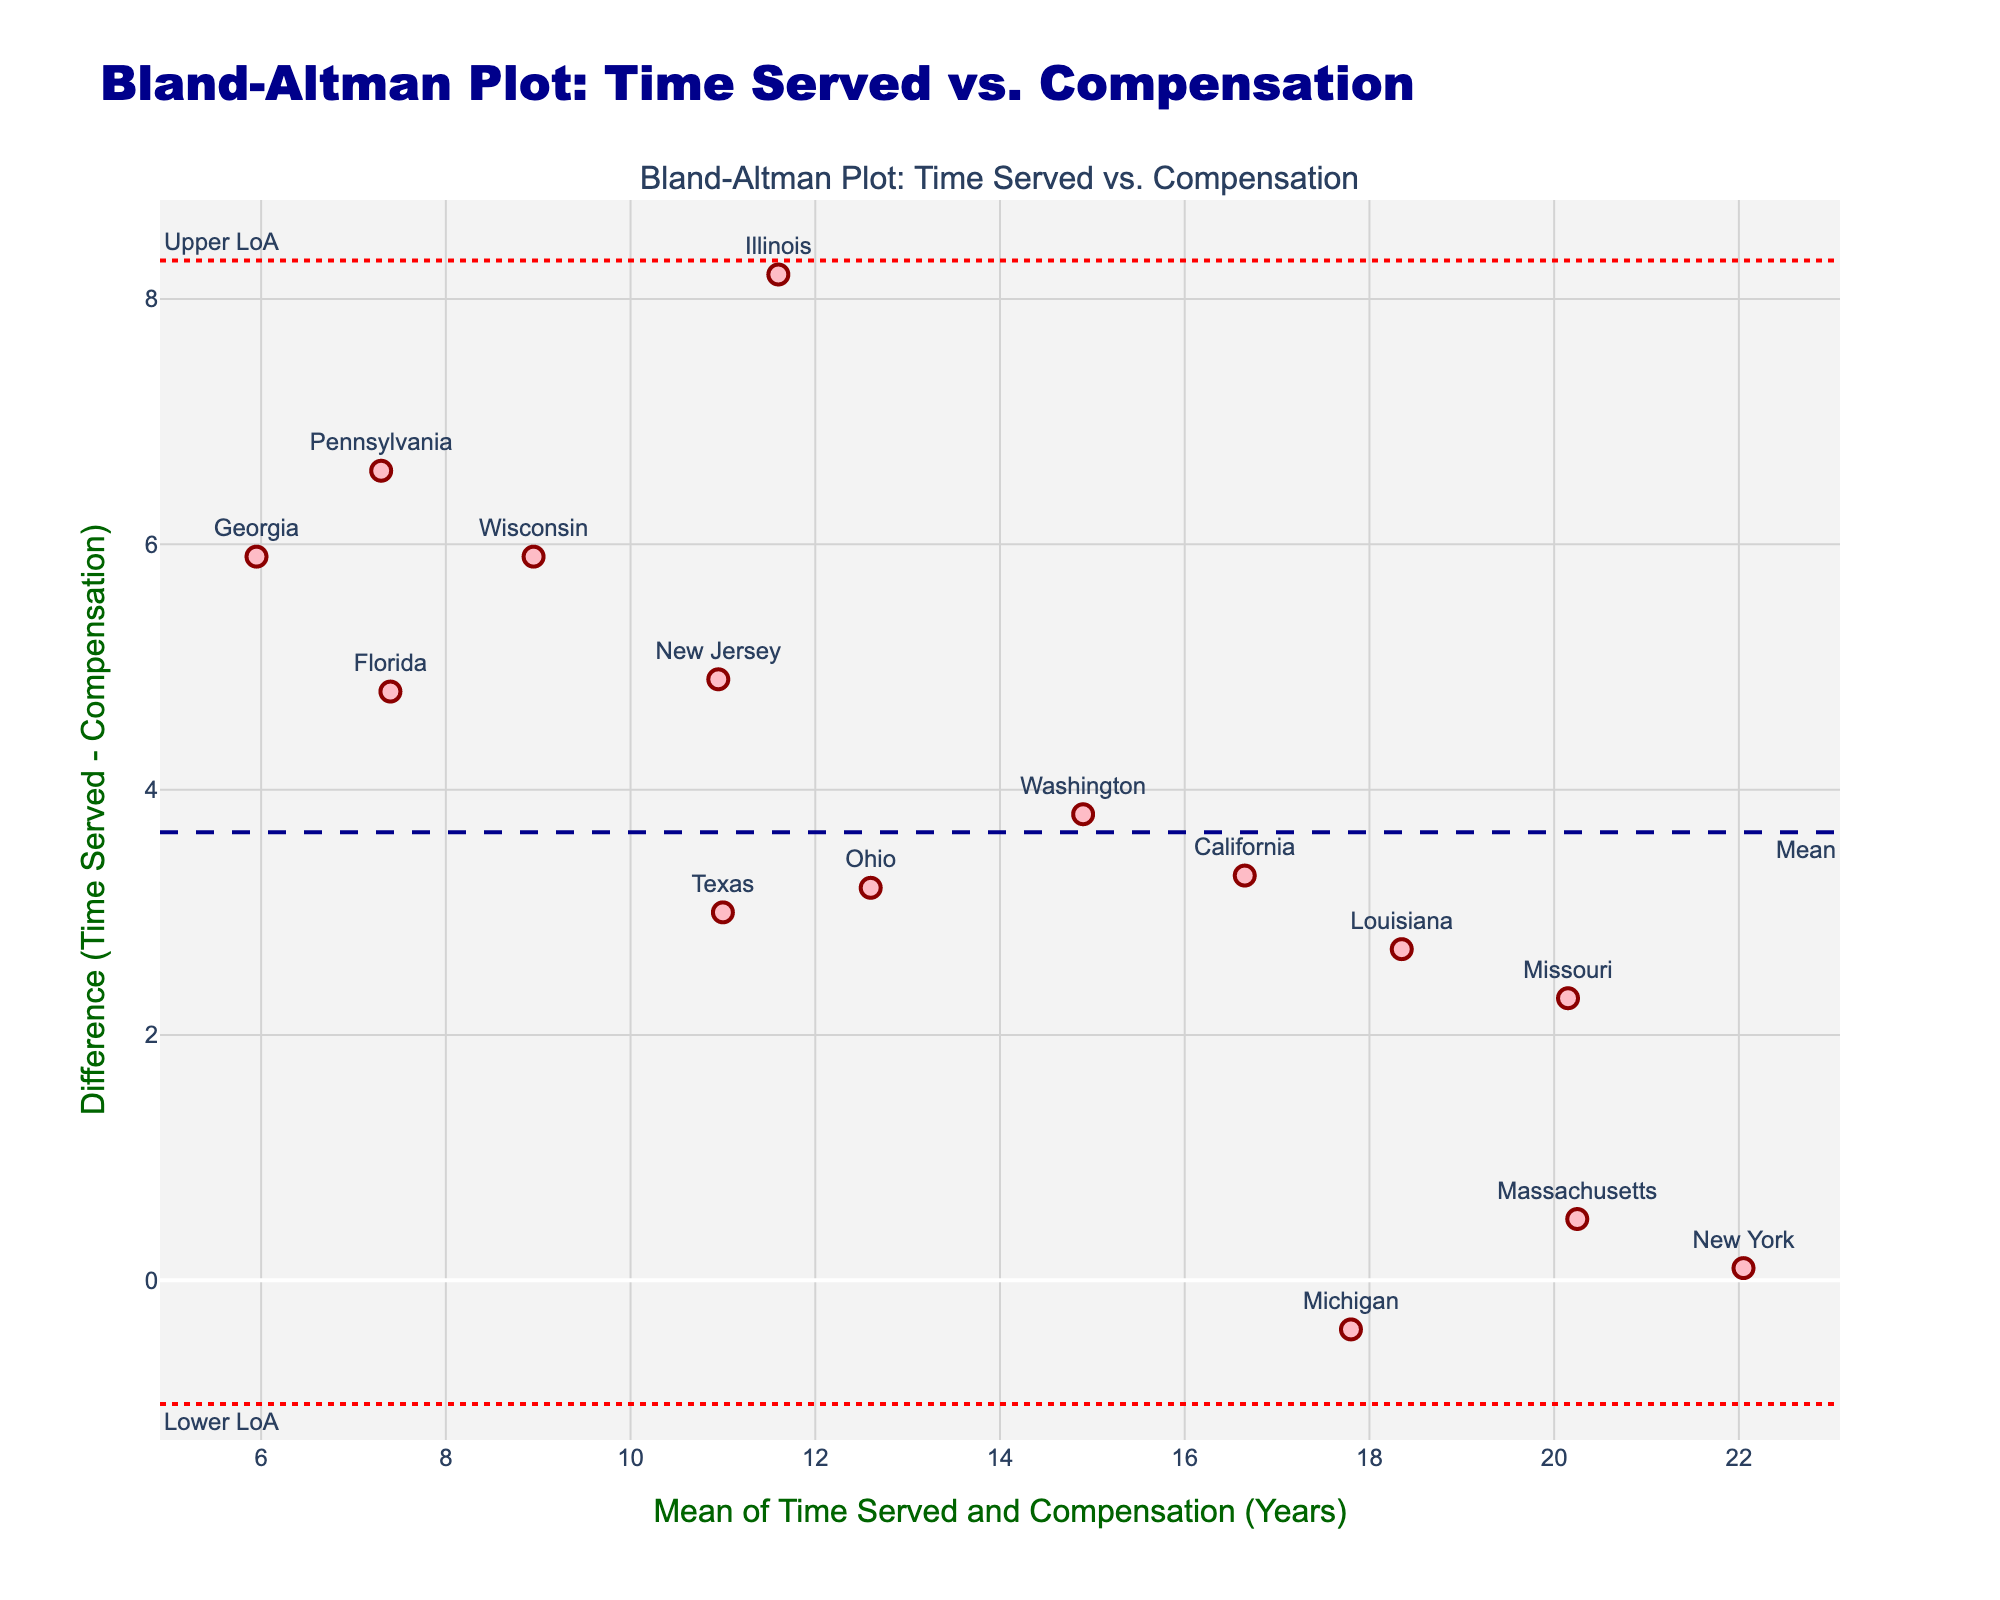What is the title of the plot? The title of the plot can be found at the top center of the figure. It reads, "Bland-Altman Plot: Time Served vs. Compensation".
Answer: Bland-Altman Plot: Time Served vs. Compensation What are the x-axis and y-axis labels of the plot? The x-axis and y-axis labels are shown adjacent to each axis. The x-axis label is "Mean of Time Served and Compensation (Years)", and the y-axis label is "Difference (Time Served - Compensation)".
Answer: Mean of Time Served and Compensation (Years), Difference (Time Served - Compensation) How many data points are shown in the plot? The number of data points corresponds to the number of markers visible in the plot. Each marker represents a state. By counting the markers, we find that there are 15 data points.
Answer: 15 What do the dotted lines represent in the plot? The dotted lines are located at specific y-values on the plot. These lines represent the Limits of Agreement (LoA). The annotation next to the upper dotted line says "Upper LoA", and the one next to the lower dotted line says "Lower LoA".
Answer: Limits of Agreement (LoA) What is the mean difference according to the plot? The mean difference line is represented by a dashed line, annotated as "Mean" on the plot. The actual y-value of this line is slightly below zero.
Answer: Slightly below zero Which state has the highest mean of time served and compensation? To determine the state with the highest mean, find the marker on the rightmost side of the x-axis, since the x-axis represents the mean. The rightmost marker corresponds to New York.
Answer: New York Which state shows the largest discrepancy between time served and compensation? The largest discrepancy is represented by the data point with the highest absolute value on the y-axis (difference). The difference is greatest for New York, as its marker is the farthest from the x-axis.
Answer: New York For which state is the mean closest to zero? Look for the data point closest to the origin (0,0) on the x-axis, i.e., the point closest to zero on the plot. This corresponds to Pennsylvania.
Answer: Pennsylvania How does the variance of differences in this plot inform you about the consistency between time served and compensation awarded? Variance in differences reflects the spread of discrepancies. A smaller spread means higher consistency, whereas a larger spread indicates greater variability. Here, there is a noticeable spread, suggesting inconsistency.
Answer: Suggests inconsistency Is there any trend visible between the mean and the differences in time served and compensation? Check if there's an upward or downward overall slope among the data points. The points seem scattered without a clear linear trend, indicating no obvious relationship.
Answer: No clear trend 